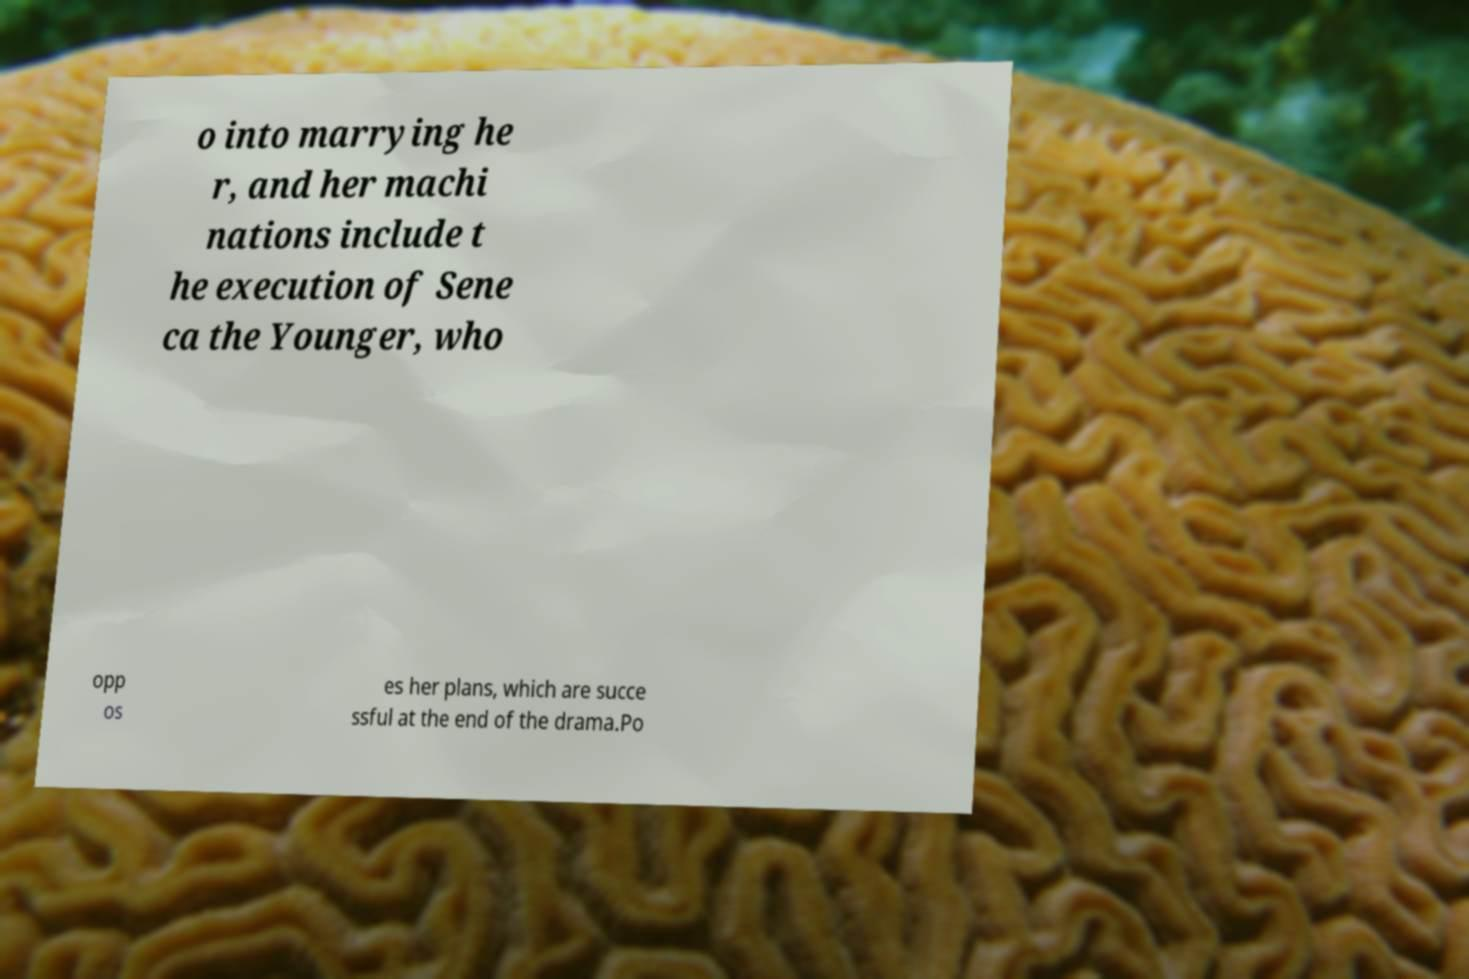What messages or text are displayed in this image? I need them in a readable, typed format. o into marrying he r, and her machi nations include t he execution of Sene ca the Younger, who opp os es her plans, which are succe ssful at the end of the drama.Po 